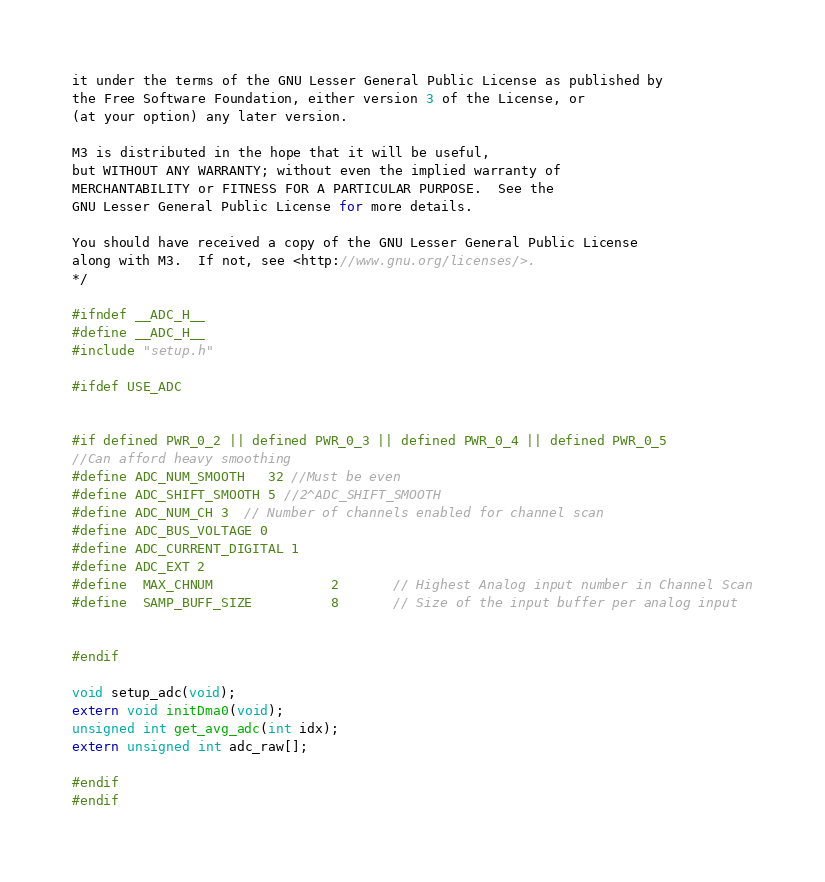<code> <loc_0><loc_0><loc_500><loc_500><_C_>it under the terms of the GNU Lesser General Public License as published by
the Free Software Foundation, either version 3 of the License, or
(at your option) any later version.

M3 is distributed in the hope that it will be useful,
but WITHOUT ANY WARRANTY; without even the implied warranty of
MERCHANTABILITY or FITNESS FOR A PARTICULAR PURPOSE.  See the
GNU Lesser General Public License for more details.

You should have received a copy of the GNU Lesser General Public License
along with M3.  If not, see <http://www.gnu.org/licenses/>.
*/

#ifndef __ADC_H__
#define __ADC_H__ 
#include "setup.h"

#ifdef USE_ADC


#if defined PWR_0_2 || defined PWR_0_3 || defined PWR_0_4 || defined PWR_0_5
//Can afford heavy smoothing
#define ADC_NUM_SMOOTH	32 //Must be even
#define ADC_SHIFT_SMOOTH 5 //2^ADC_SHIFT_SMOOTH
#define ADC_NUM_CH 3  // Number of channels enabled for channel scan
#define ADC_BUS_VOLTAGE 0
#define ADC_CURRENT_DIGITAL 1
#define ADC_EXT 2
#define  MAX_CHNUM	 			2		// Highest Analog input number in Channel Scan
#define  SAMP_BUFF_SIZE	 		8		// Size of the input buffer per analog input


#endif

void setup_adc(void);
extern void initDma0(void);
unsigned int get_avg_adc(int idx);
extern unsigned int adc_raw[];

#endif
#endif
</code> 